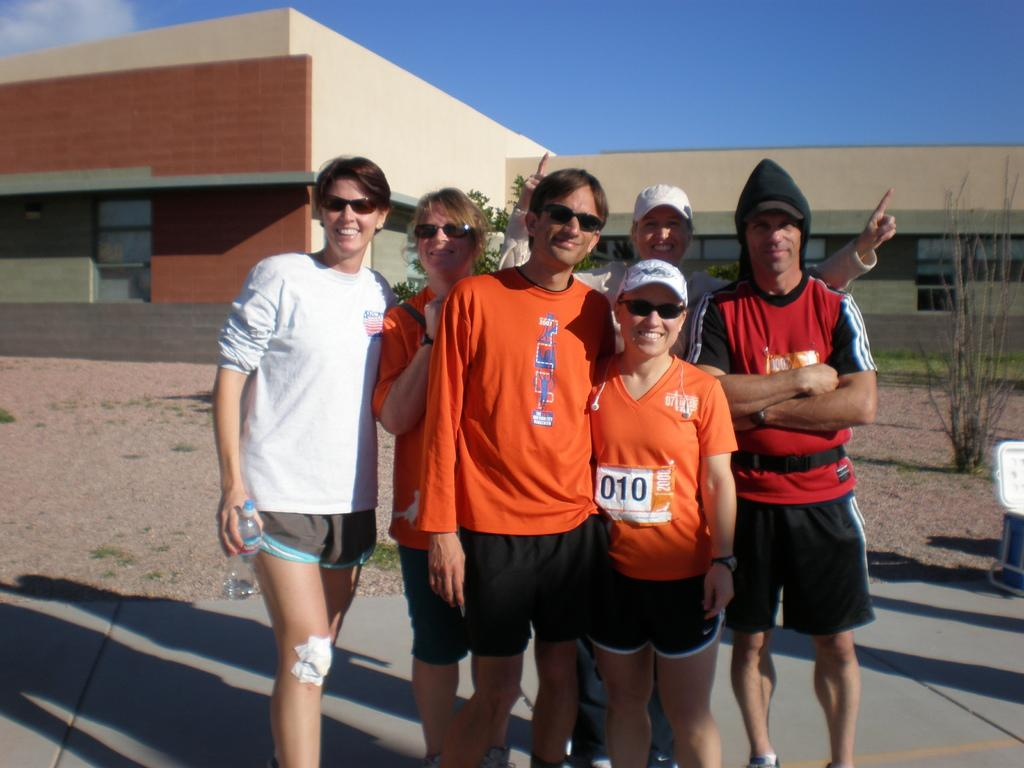Who or what can be seen in the image? There are people in the image. What can be seen in the distance behind the people? There are buildings and trees in the background of the image. Can you describe the object on the right side of the image? There is an object on the right side of the image, but its specific details are not clear from the provided facts. What is visible in the sky in the image? The sky is visible in the background of the image. What type of hat is the nation wearing in the image? There is no nation or hat present in the image. How many slippers can be seen on the people in the image? There is no information about slippers or footwear in the image. 